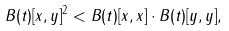Convert formula to latex. <formula><loc_0><loc_0><loc_500><loc_500>B ( t ) [ x , y ] ^ { 2 } < B ( t ) [ x , x ] \cdot B ( t ) [ y , y ] ,</formula> 